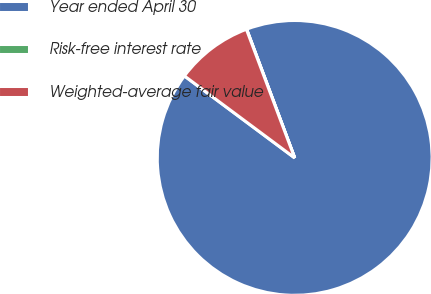Convert chart to OTSL. <chart><loc_0><loc_0><loc_500><loc_500><pie_chart><fcel>Year ended April 30<fcel>Risk-free interest rate<fcel>Weighted-average fair value<nl><fcel>90.86%<fcel>0.03%<fcel>9.11%<nl></chart> 